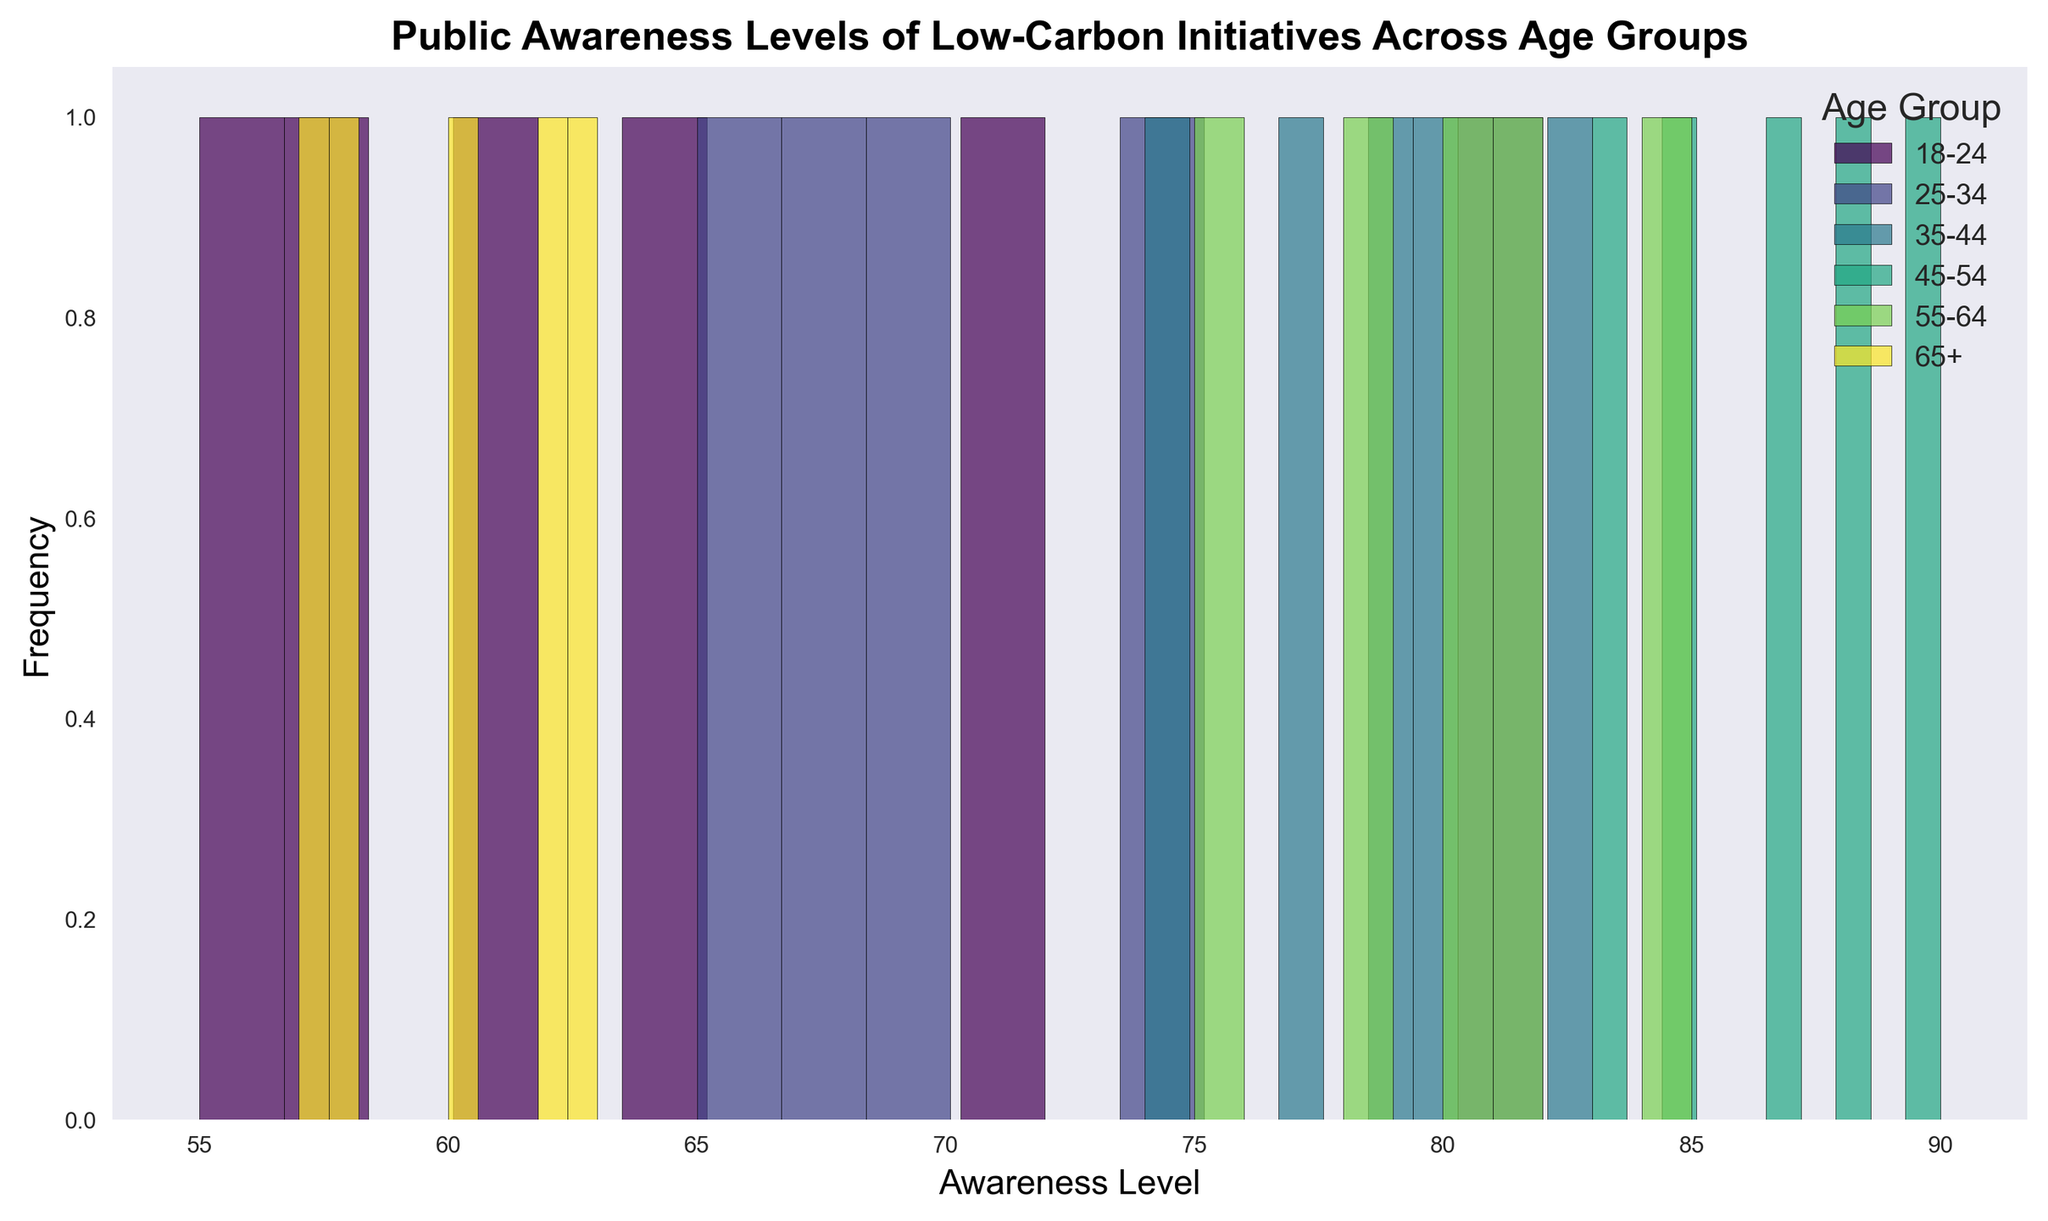What age group has the highest peak in the histogram? The 45-54 age group has the highest peak, indicating the highest frequency of awareness levels between 85 and 90. This can be visually identified by looking at which bars are tallest among different age groups.
Answer: 45-54 How does the average awareness level for the 35-44 age group compare to the 55-64 age group? Calculate the average for each age group: For 35-44, (80 + 77 + 83 + 74 + 79) / 5 = 78.6. For 55-64, (78 + 81 + 85 + 80 + 75) / 5 = 79.8. Comparatively, the 55-64 age group has a slightly higher average awareness level.
Answer: 55-64 has a higher average Which age group has the widest spread of awareness levels? The spread can be observed by looking at the range of the histogram bins used by each age group. The 18-24 age group appears to have the widest spread, covering awareness levels from 55 to 72.
Answer: 18-24 What is the most common awareness level range for the 25-34 age group? The histogram for the 25-34 age group shows the highest frequency in the bins covering awareness levels approximately between 65 and 75.
Answer: 65-75 Which age group has the least variation in awareness levels? Variation can be visually identified by the range of the histogram. The 45-54 age group has the least variation, as its awareness levels are tightly grouped around the higher end, between 83 to 90.
Answer: 45-54 What is the frequency of awareness levels between 60 and 65 for the 65+ age group? Count the bars representing awareness levels within 60 to 65 in the histogram. Visually, there appear to be 3 bars for this range.
Answer: 3 Compare the peak awareness levels between the 18-24 and 65+ age groups. The 18-24 group peaks roughly around the awareness level of 58-72 while the 65+ group peaks around 60-63. The 18-24 group has a broader peak compared to the 65+ group.
Answer: 18-24 peaks higher How many bins do we see in the histogram for the 35-44 age group? Count the number of bars (bins) in the histogram corresponding to the 35-44 age group. We see 5 bins.
Answer: 5 What is the range of awareness levels for the 25-34 age group? The lowest awareness level for the 25-34 age group is around 65 and the highest is 82. So, the range is 82 - 65 = 17.
Answer: 17 Are there any age groups with significant overlaps in awareness levels? Compare the histograms for different groups. Groups 18-24 and 25-34 show some overlap in the awareness level ranges between 65 and 72, indicating significant overlapping.
Answer: Yes, 18-24 and 25-34 